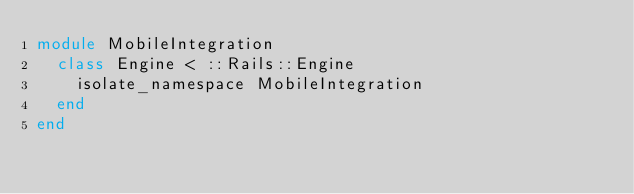<code> <loc_0><loc_0><loc_500><loc_500><_Ruby_>module MobileIntegration
  class Engine < ::Rails::Engine
    isolate_namespace MobileIntegration
  end
end
</code> 